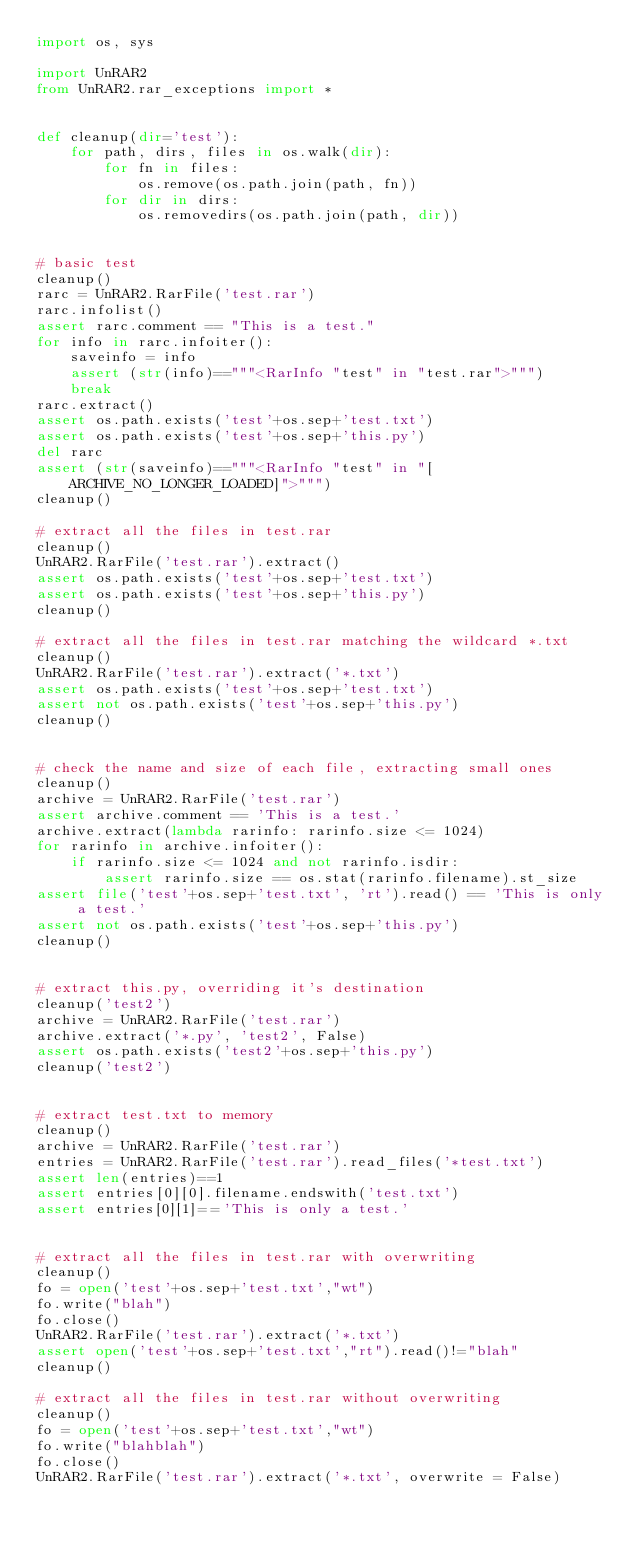Convert code to text. <code><loc_0><loc_0><loc_500><loc_500><_Python_>import os, sys

import UnRAR2
from UnRAR2.rar_exceptions import *


def cleanup(dir='test'):
    for path, dirs, files in os.walk(dir):
        for fn in files:
            os.remove(os.path.join(path, fn))
        for dir in dirs:
            os.removedirs(os.path.join(path, dir))


# basic test
cleanup()
rarc = UnRAR2.RarFile('test.rar')
rarc.infolist()
assert rarc.comment == "This is a test."
for info in rarc.infoiter():
    saveinfo = info
    assert (str(info)=="""<RarInfo "test" in "test.rar">""")
    break
rarc.extract()
assert os.path.exists('test'+os.sep+'test.txt')
assert os.path.exists('test'+os.sep+'this.py')
del rarc
assert (str(saveinfo)=="""<RarInfo "test" in "[ARCHIVE_NO_LONGER_LOADED]">""")
cleanup()

# extract all the files in test.rar
cleanup()
UnRAR2.RarFile('test.rar').extract()
assert os.path.exists('test'+os.sep+'test.txt')
assert os.path.exists('test'+os.sep+'this.py')
cleanup()

# extract all the files in test.rar matching the wildcard *.txt
cleanup()
UnRAR2.RarFile('test.rar').extract('*.txt')
assert os.path.exists('test'+os.sep+'test.txt')
assert not os.path.exists('test'+os.sep+'this.py')
cleanup()


# check the name and size of each file, extracting small ones
cleanup()
archive = UnRAR2.RarFile('test.rar')
assert archive.comment == 'This is a test.'
archive.extract(lambda rarinfo: rarinfo.size <= 1024)
for rarinfo in archive.infoiter():
    if rarinfo.size <= 1024 and not rarinfo.isdir:
        assert rarinfo.size == os.stat(rarinfo.filename).st_size
assert file('test'+os.sep+'test.txt', 'rt').read() == 'This is only a test.'
assert not os.path.exists('test'+os.sep+'this.py')
cleanup()


# extract this.py, overriding it's destination
cleanup('test2')
archive = UnRAR2.RarFile('test.rar')
archive.extract('*.py', 'test2', False)
assert os.path.exists('test2'+os.sep+'this.py')
cleanup('test2')


# extract test.txt to memory
cleanup()
archive = UnRAR2.RarFile('test.rar')
entries = UnRAR2.RarFile('test.rar').read_files('*test.txt')
assert len(entries)==1
assert entries[0][0].filename.endswith('test.txt')
assert entries[0][1]=='This is only a test.'


# extract all the files in test.rar with overwriting
cleanup()
fo = open('test'+os.sep+'test.txt',"wt")
fo.write("blah")
fo.close()
UnRAR2.RarFile('test.rar').extract('*.txt')
assert open('test'+os.sep+'test.txt',"rt").read()!="blah"
cleanup()

# extract all the files in test.rar without overwriting
cleanup()
fo = open('test'+os.sep+'test.txt',"wt")
fo.write("blahblah")
fo.close()
UnRAR2.RarFile('test.rar').extract('*.txt', overwrite = False)</code> 